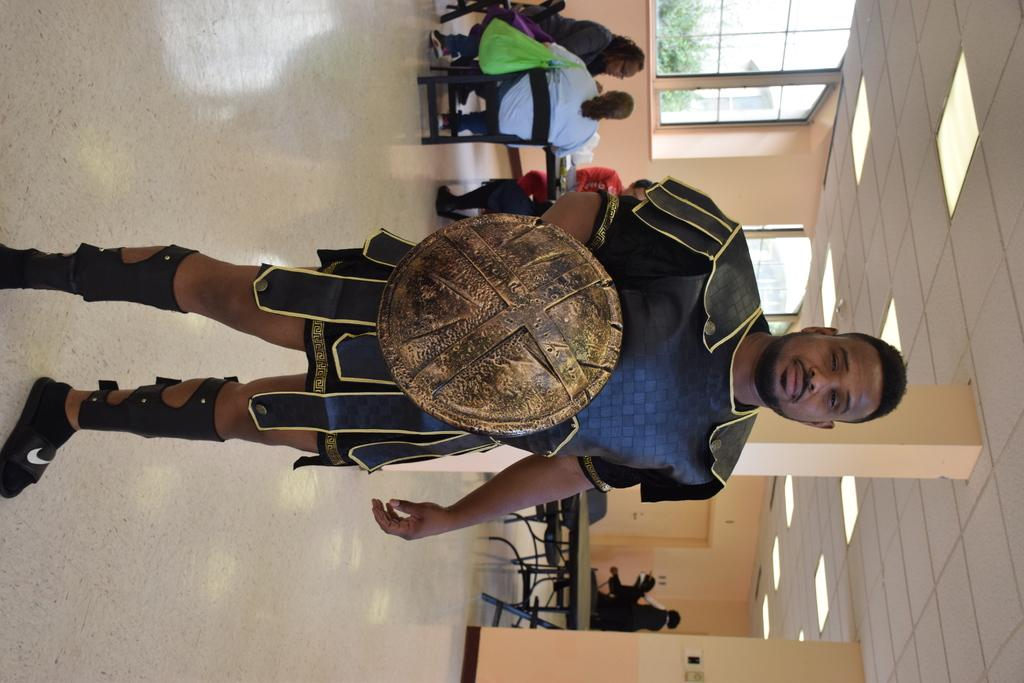What is the primary subject of the image? There is a person standing in the image. What is the person holding in the image? The person is holding an object. What are the other people in the image doing? There are people seated on chairs in the image. What is in front of the seated people? There are tables in front of the seated people. What type of night lift can be seen in the image? There is no night lift present in the image. 